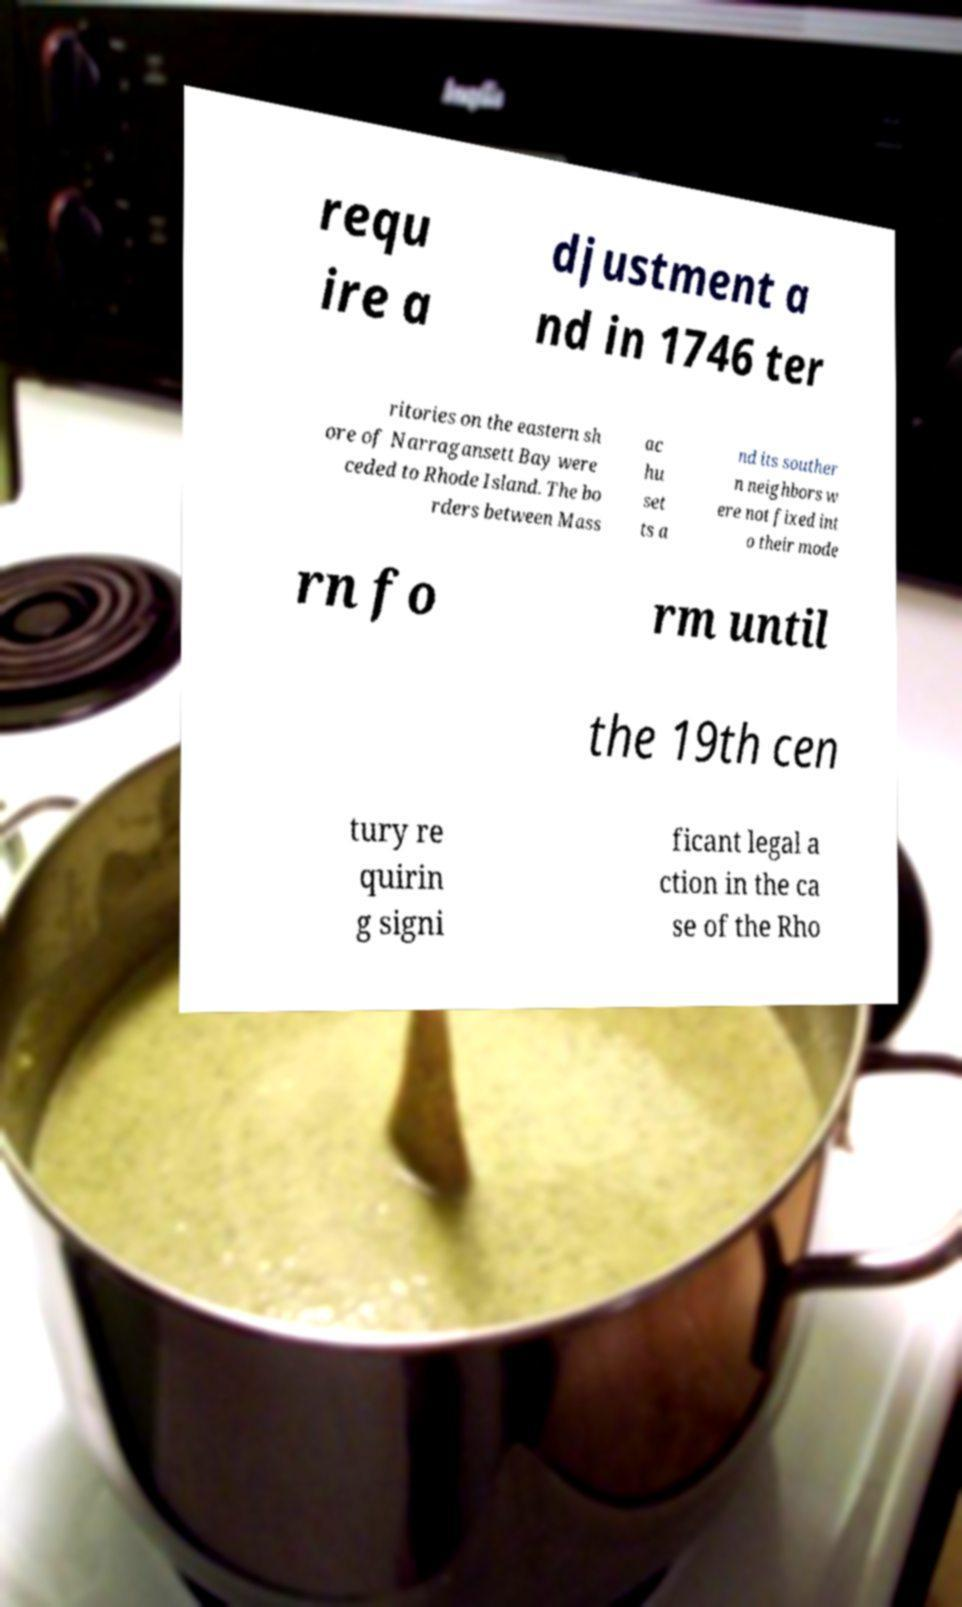Could you extract and type out the text from this image? requ ire a djustment a nd in 1746 ter ritories on the eastern sh ore of Narragansett Bay were ceded to Rhode Island. The bo rders between Mass ac hu set ts a nd its souther n neighbors w ere not fixed int o their mode rn fo rm until the 19th cen tury re quirin g signi ficant legal a ction in the ca se of the Rho 